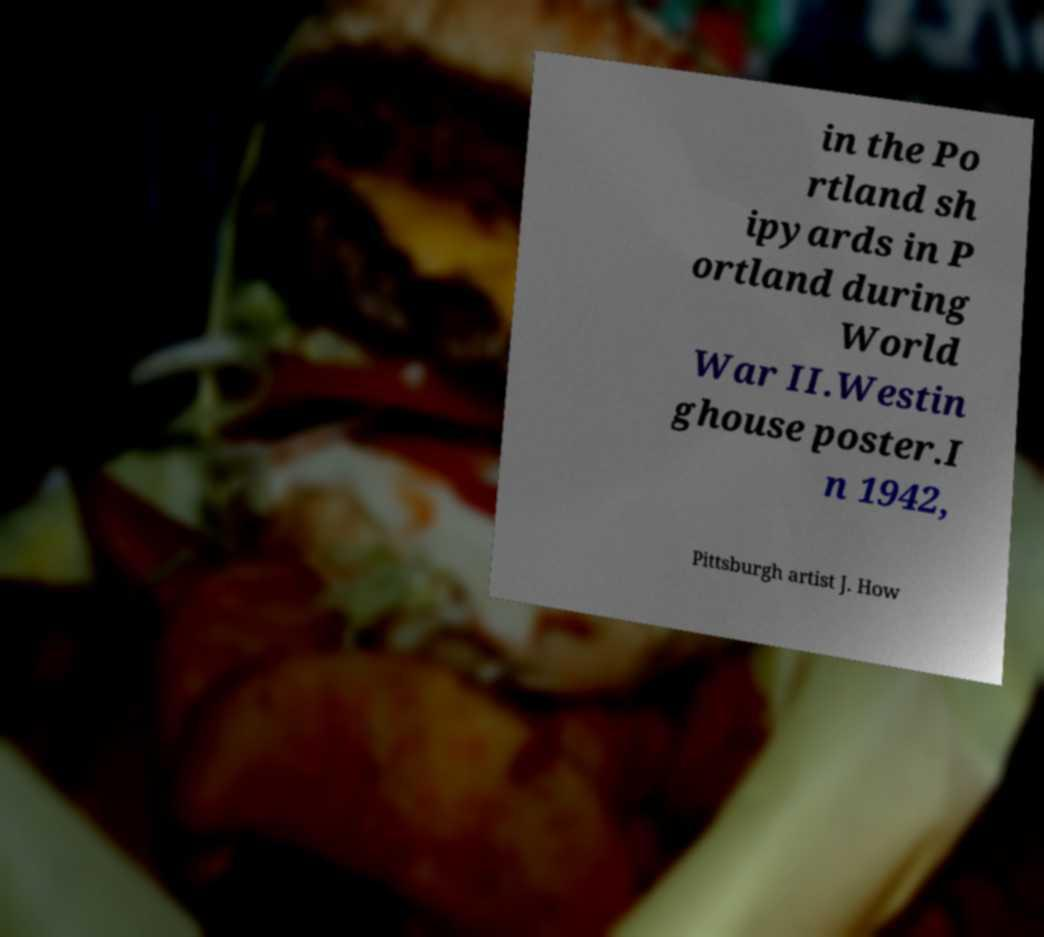I need the written content from this picture converted into text. Can you do that? in the Po rtland sh ipyards in P ortland during World War II.Westin ghouse poster.I n 1942, Pittsburgh artist J. How 